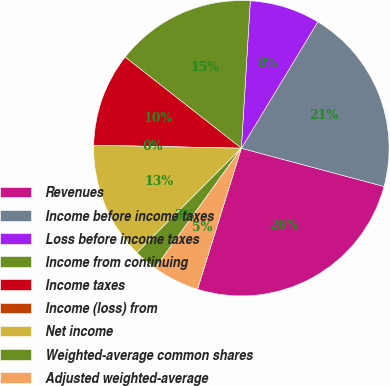<chart> <loc_0><loc_0><loc_500><loc_500><pie_chart><fcel>Revenues<fcel>Income before income taxes<fcel>Loss before income taxes<fcel>Income from continuing<fcel>Income taxes<fcel>Income (loss) from<fcel>Net income<fcel>Weighted-average common shares<fcel>Adjusted weighted-average<nl><fcel>25.63%<fcel>20.51%<fcel>7.69%<fcel>15.38%<fcel>10.26%<fcel>0.0%<fcel>12.82%<fcel>2.57%<fcel>5.13%<nl></chart> 